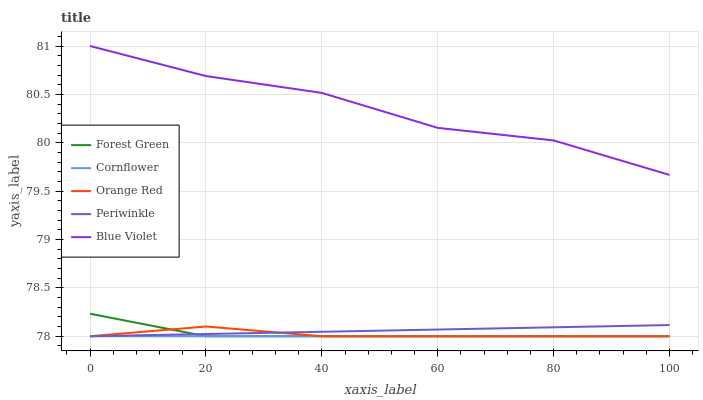Does Cornflower have the minimum area under the curve?
Answer yes or no. Yes. Does Blue Violet have the maximum area under the curve?
Answer yes or no. Yes. Does Forest Green have the minimum area under the curve?
Answer yes or no. No. Does Forest Green have the maximum area under the curve?
Answer yes or no. No. Is Cornflower the smoothest?
Answer yes or no. Yes. Is Blue Violet the roughest?
Answer yes or no. Yes. Is Forest Green the smoothest?
Answer yes or no. No. Is Forest Green the roughest?
Answer yes or no. No. Does Cornflower have the lowest value?
Answer yes or no. Yes. Does Blue Violet have the lowest value?
Answer yes or no. No. Does Blue Violet have the highest value?
Answer yes or no. Yes. Does Forest Green have the highest value?
Answer yes or no. No. Is Forest Green less than Blue Violet?
Answer yes or no. Yes. Is Blue Violet greater than Forest Green?
Answer yes or no. Yes. Does Orange Red intersect Cornflower?
Answer yes or no. Yes. Is Orange Red less than Cornflower?
Answer yes or no. No. Is Orange Red greater than Cornflower?
Answer yes or no. No. Does Forest Green intersect Blue Violet?
Answer yes or no. No. 